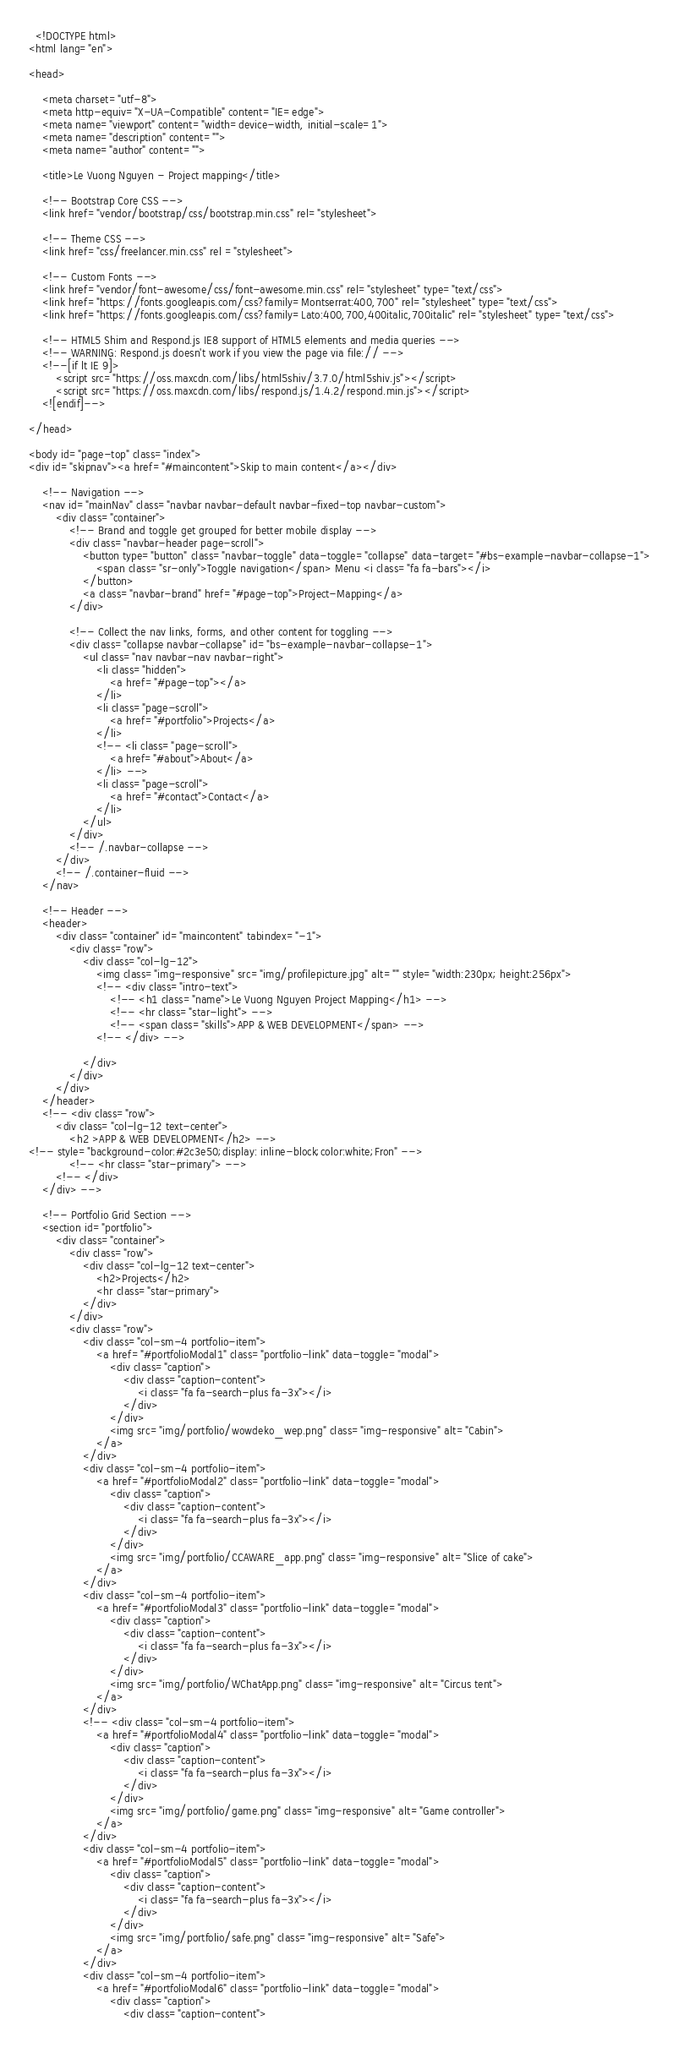Convert code to text. <code><loc_0><loc_0><loc_500><loc_500><_HTML_>  <!DOCTYPE html>
<html lang="en">

<head>

    <meta charset="utf-8">
    <meta http-equiv="X-UA-Compatible" content="IE=edge">
    <meta name="viewport" content="width=device-width, initial-scale=1">
    <meta name="description" content="">
    <meta name="author" content="">

    <title>Le Vuong Nguyen - Project mapping</title>

    <!-- Bootstrap Core CSS -->
    <link href="vendor/bootstrap/css/bootstrap.min.css" rel="stylesheet">

    <!-- Theme CSS -->
    <link href="css/freelancer.min.css" rel ="stylesheet">

    <!-- Custom Fonts -->
    <link href="vendor/font-awesome/css/font-awesome.min.css" rel="stylesheet" type="text/css">
    <link href="https://fonts.googleapis.com/css?family=Montserrat:400,700" rel="stylesheet" type="text/css">
    <link href="https://fonts.googleapis.com/css?family=Lato:400,700,400italic,700italic" rel="stylesheet" type="text/css">

    <!-- HTML5 Shim and Respond.js IE8 support of HTML5 elements and media queries -->
    <!-- WARNING: Respond.js doesn't work if you view the page via file:// -->
    <!--[if lt IE 9]>
        <script src="https://oss.maxcdn.com/libs/html5shiv/3.7.0/html5shiv.js"></script>
        <script src="https://oss.maxcdn.com/libs/respond.js/1.4.2/respond.min.js"></script>
    <![endif]-->

</head>

<body id="page-top" class="index">
<div id="skipnav"><a href="#maincontent">Skip to main content</a></div>

    <!-- Navigation -->
    <nav id="mainNav" class="navbar navbar-default navbar-fixed-top navbar-custom">
        <div class="container">
            <!-- Brand and toggle get grouped for better mobile display -->
            <div class="navbar-header page-scroll">
                <button type="button" class="navbar-toggle" data-toggle="collapse" data-target="#bs-example-navbar-collapse-1">
                    <span class="sr-only">Toggle navigation</span> Menu <i class="fa fa-bars"></i>
                </button>
                <a class="navbar-brand" href="#page-top">Project-Mapping</a>
            </div>

            <!-- Collect the nav links, forms, and other content for toggling -->
            <div class="collapse navbar-collapse" id="bs-example-navbar-collapse-1">
                <ul class="nav navbar-nav navbar-right">
                    <li class="hidden">
                        <a href="#page-top"></a>
                    </li>
                    <li class="page-scroll">
                        <a href="#portfolio">Projects</a>
                    </li>
                    <!-- <li class="page-scroll">
                        <a href="#about">About</a>
                    </li> -->
                    <li class="page-scroll">
                        <a href="#contact">Contact</a>
                    </li>
                </ul>
            </div>
            <!-- /.navbar-collapse -->
        </div>
        <!-- /.container-fluid -->
    </nav>

    <!-- Header -->
    <header>
        <div class="container" id="maincontent" tabindex="-1">
            <div class="row">
                <div class="col-lg-12">
                    <img class="img-responsive" src="img/profilepicture.jpg" alt="" style="width:230px; height:256px">
                    <!-- <div class="intro-text">
                        <!-- <h1 class="name">Le Vuong Nguyen Project Mapping</h1> -->
                        <!-- <hr class="star-light"> -->
                        <!-- <span class="skills">APP & WEB DEVELOPMENT</span> -->
                    <!-- </div> -->

                </div>
            </div>
        </div>
    </header>
    <!-- <div class="row">
        <div class="col-lg-12 text-center">
            <h2 >APP & WEB DEVELOPMENT</h2> -->
<!-- style="background-color:#2c3e50;display: inline-block;color:white;Fron" -->
            <!-- <hr class="star-primary"> -->
        <!-- </div>
    </div> -->

    <!-- Portfolio Grid Section -->
    <section id="portfolio">
        <div class="container">
            <div class="row">
                <div class="col-lg-12 text-center">
                    <h2>Projects</h2>
                    <hr class="star-primary">
                </div>
            </div>
            <div class="row">
                <div class="col-sm-4 portfolio-item">
                    <a href="#portfolioModal1" class="portfolio-link" data-toggle="modal">
                        <div class="caption">
                            <div class="caption-content">
                                <i class="fa fa-search-plus fa-3x"></i>
                            </div>
                        </div>
                        <img src="img/portfolio/wowdeko_wep.png" class="img-responsive" alt="Cabin">
                    </a>
                </div>
                <div class="col-sm-4 portfolio-item">
                    <a href="#portfolioModal2" class="portfolio-link" data-toggle="modal">
                        <div class="caption">
                            <div class="caption-content">
                                <i class="fa fa-search-plus fa-3x"></i>
                            </div>
                        </div>
                        <img src="img/portfolio/CCAWARE_app.png" class="img-responsive" alt="Slice of cake">
                    </a>
                </div>
                <div class="col-sm-4 portfolio-item">
                    <a href="#portfolioModal3" class="portfolio-link" data-toggle="modal">
                        <div class="caption">
                            <div class="caption-content">
                                <i class="fa fa-search-plus fa-3x"></i>
                            </div>
                        </div>
                        <img src="img/portfolio/WChatApp.png" class="img-responsive" alt="Circus tent">
                    </a>
                </div>
                <!-- <div class="col-sm-4 portfolio-item">
                    <a href="#portfolioModal4" class="portfolio-link" data-toggle="modal">
                        <div class="caption">
                            <div class="caption-content">
                                <i class="fa fa-search-plus fa-3x"></i>
                            </div>
                        </div>
                        <img src="img/portfolio/game.png" class="img-responsive" alt="Game controller">
                    </a>
                </div>
                <div class="col-sm-4 portfolio-item">
                    <a href="#portfolioModal5" class="portfolio-link" data-toggle="modal">
                        <div class="caption">
                            <div class="caption-content">
                                <i class="fa fa-search-plus fa-3x"></i>
                            </div>
                        </div>
                        <img src="img/portfolio/safe.png" class="img-responsive" alt="Safe">
                    </a>
                </div>
                <div class="col-sm-4 portfolio-item">
                    <a href="#portfolioModal6" class="portfolio-link" data-toggle="modal">
                        <div class="caption">
                            <div class="caption-content"></code> 